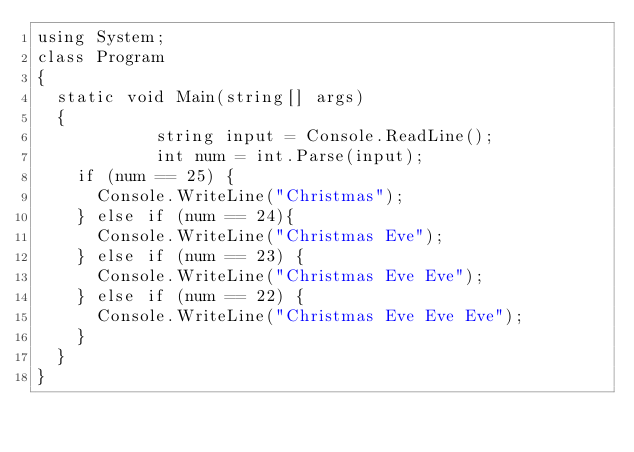<code> <loc_0><loc_0><loc_500><loc_500><_C#_>using System;
class Program
{
	static void Main(string[] args)
	{
        		string input = Console.ReadLine();
        		int num = int.Parse(input);
		if (num == 25) {
			Console.WriteLine("Christmas");
		} else if (num == 24){
			Console.WriteLine("Christmas Eve");
		} else if (num == 23) {
			Console.WriteLine("Christmas Eve Eve");
		} else if (num == 22) {
			Console.WriteLine("Christmas Eve Eve Eve");
		}
	}
}</code> 